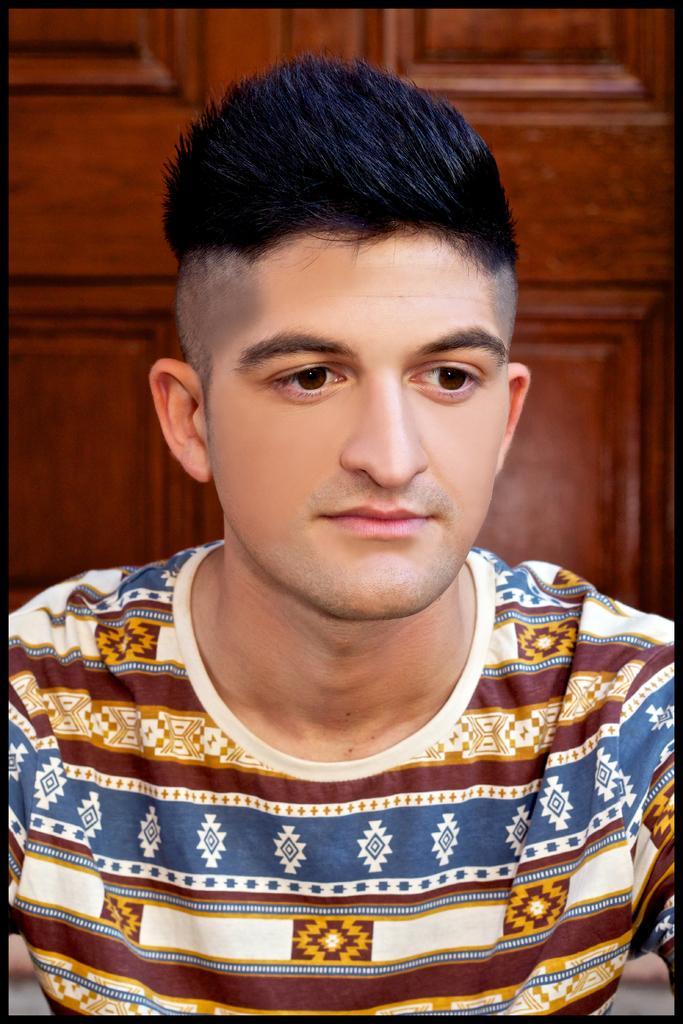Can you describe this image briefly? In this picture we can see a man. 